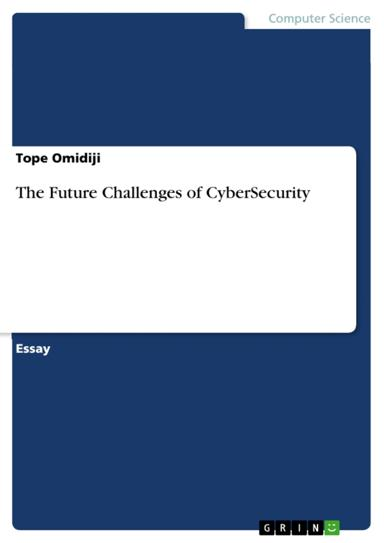In which field is the essay mentioned in the image? The essay "The Future Challenges of CyberSecurity" falls squarely within the field of Computer Science, particularly concentrating on cybersecurity. Cybersecurity is a vital Computer Science discipline that deals with the protection of computer systems and networks from digital attacks, theft, and damage to hardware, software, or data. 